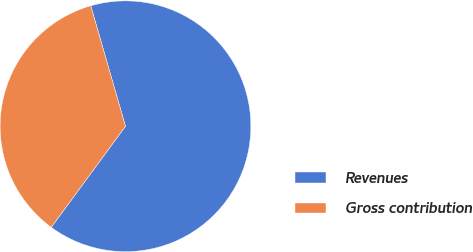<chart> <loc_0><loc_0><loc_500><loc_500><pie_chart><fcel>Revenues<fcel>Gross contribution<nl><fcel>64.55%<fcel>35.45%<nl></chart> 